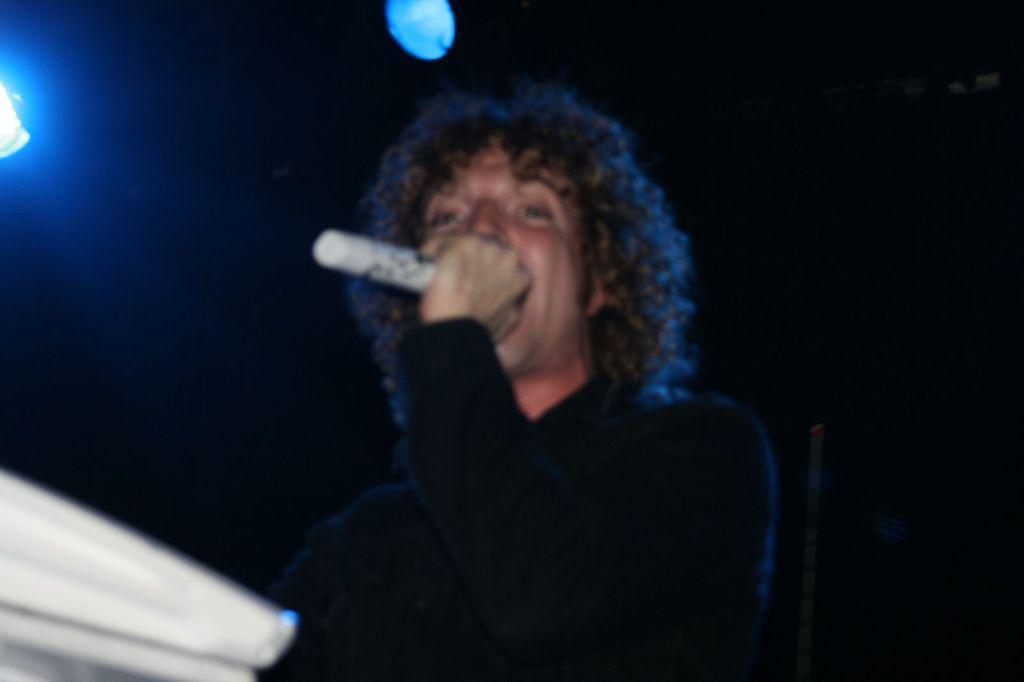What is the main subject of the image? There is a person in the image. What is the person holding in his hand? The person is holding a microphone in his hand. What can be seen at the top of the image? There are lights visible at the top of the image. What type of needle is the person using to sew in the image? There is no needle present in the image; the person is holding a microphone. Can you tell me how many calculators are visible in the image? There are no calculators present in the image. 